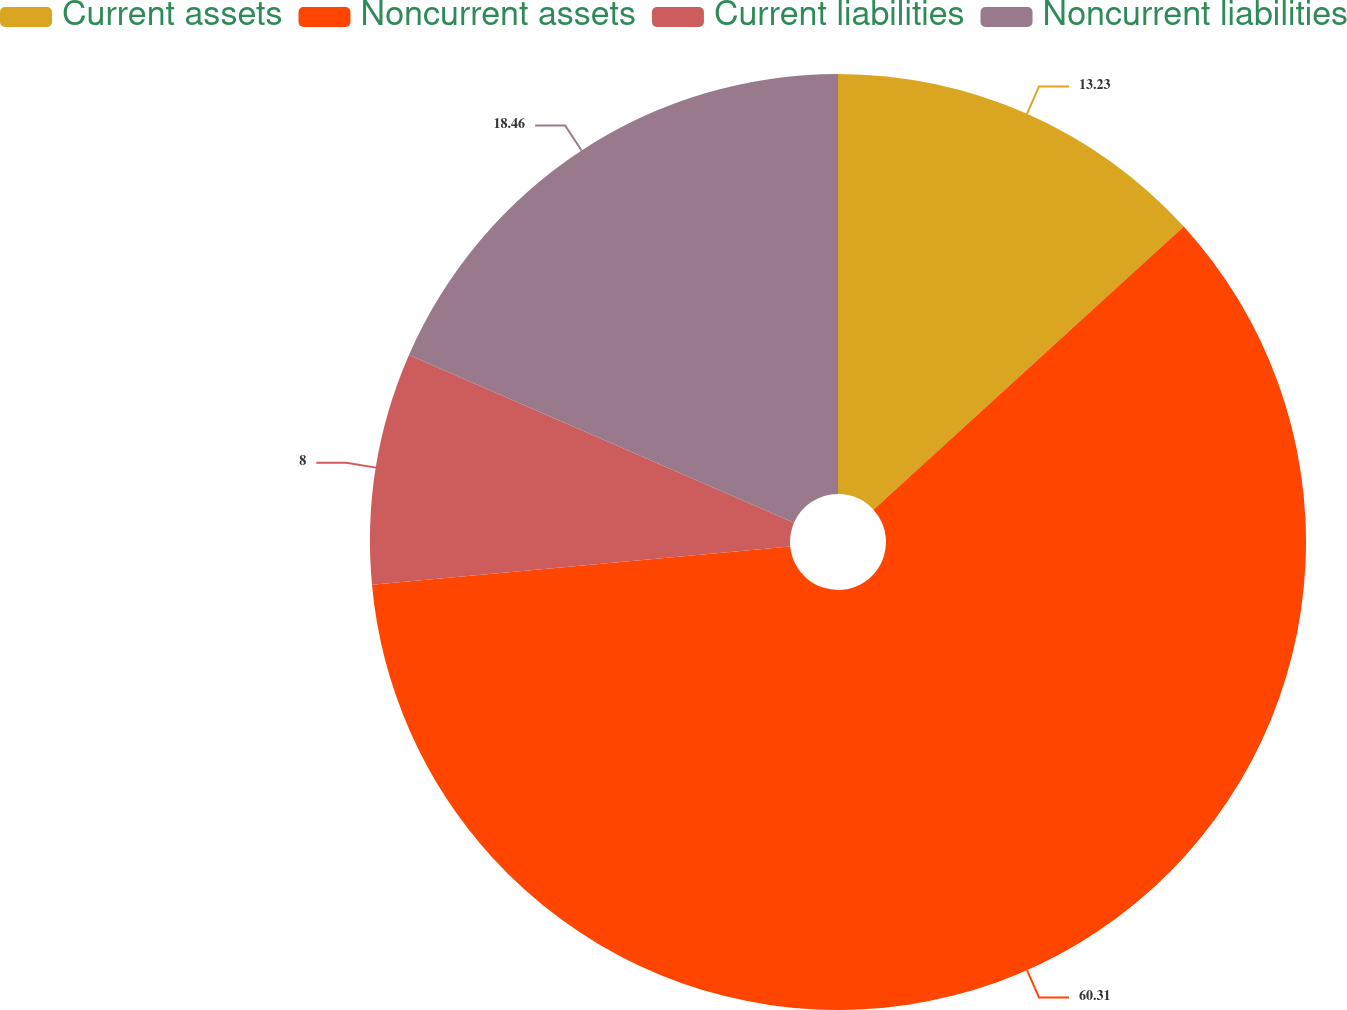<chart> <loc_0><loc_0><loc_500><loc_500><pie_chart><fcel>Current assets<fcel>Noncurrent assets<fcel>Current liabilities<fcel>Noncurrent liabilities<nl><fcel>13.23%<fcel>60.31%<fcel>8.0%<fcel>18.46%<nl></chart> 